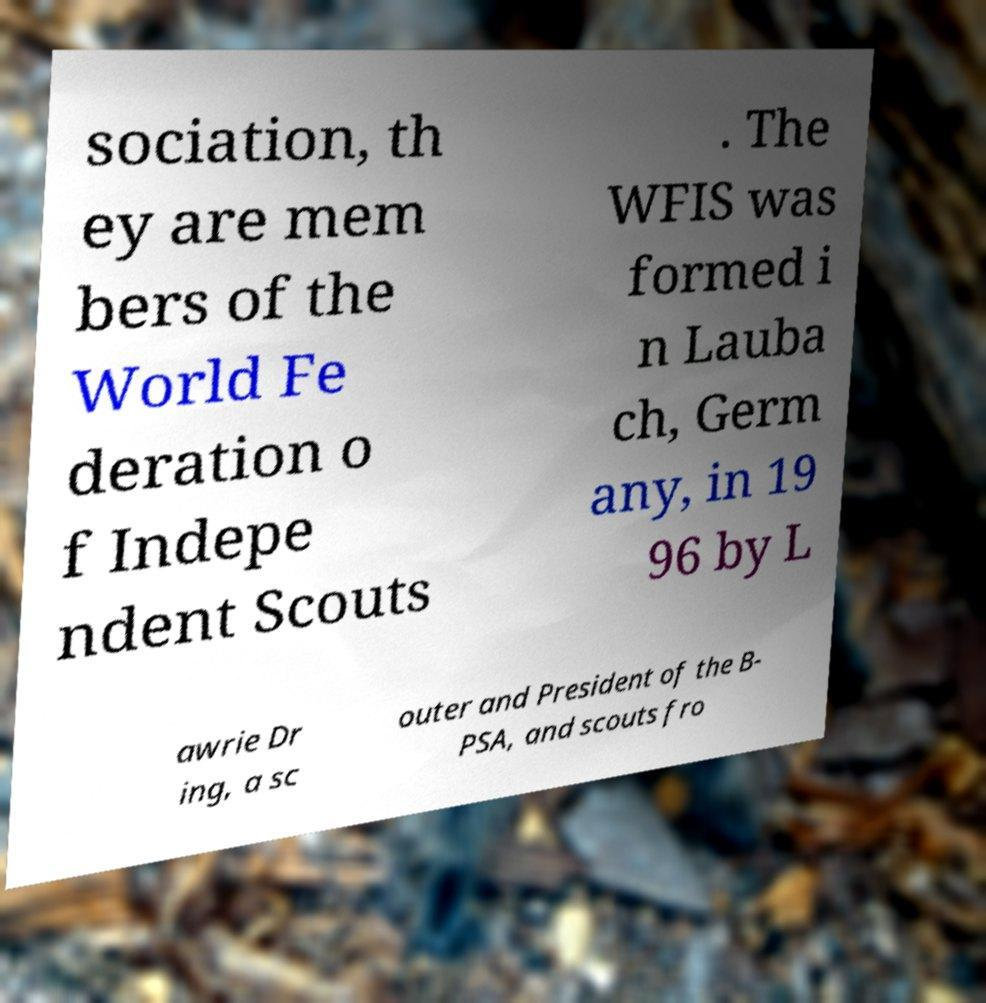There's text embedded in this image that I need extracted. Can you transcribe it verbatim? sociation, th ey are mem bers of the World Fe deration o f Indepe ndent Scouts . The WFIS was formed i n Lauba ch, Germ any, in 19 96 by L awrie Dr ing, a sc outer and President of the B- PSA, and scouts fro 